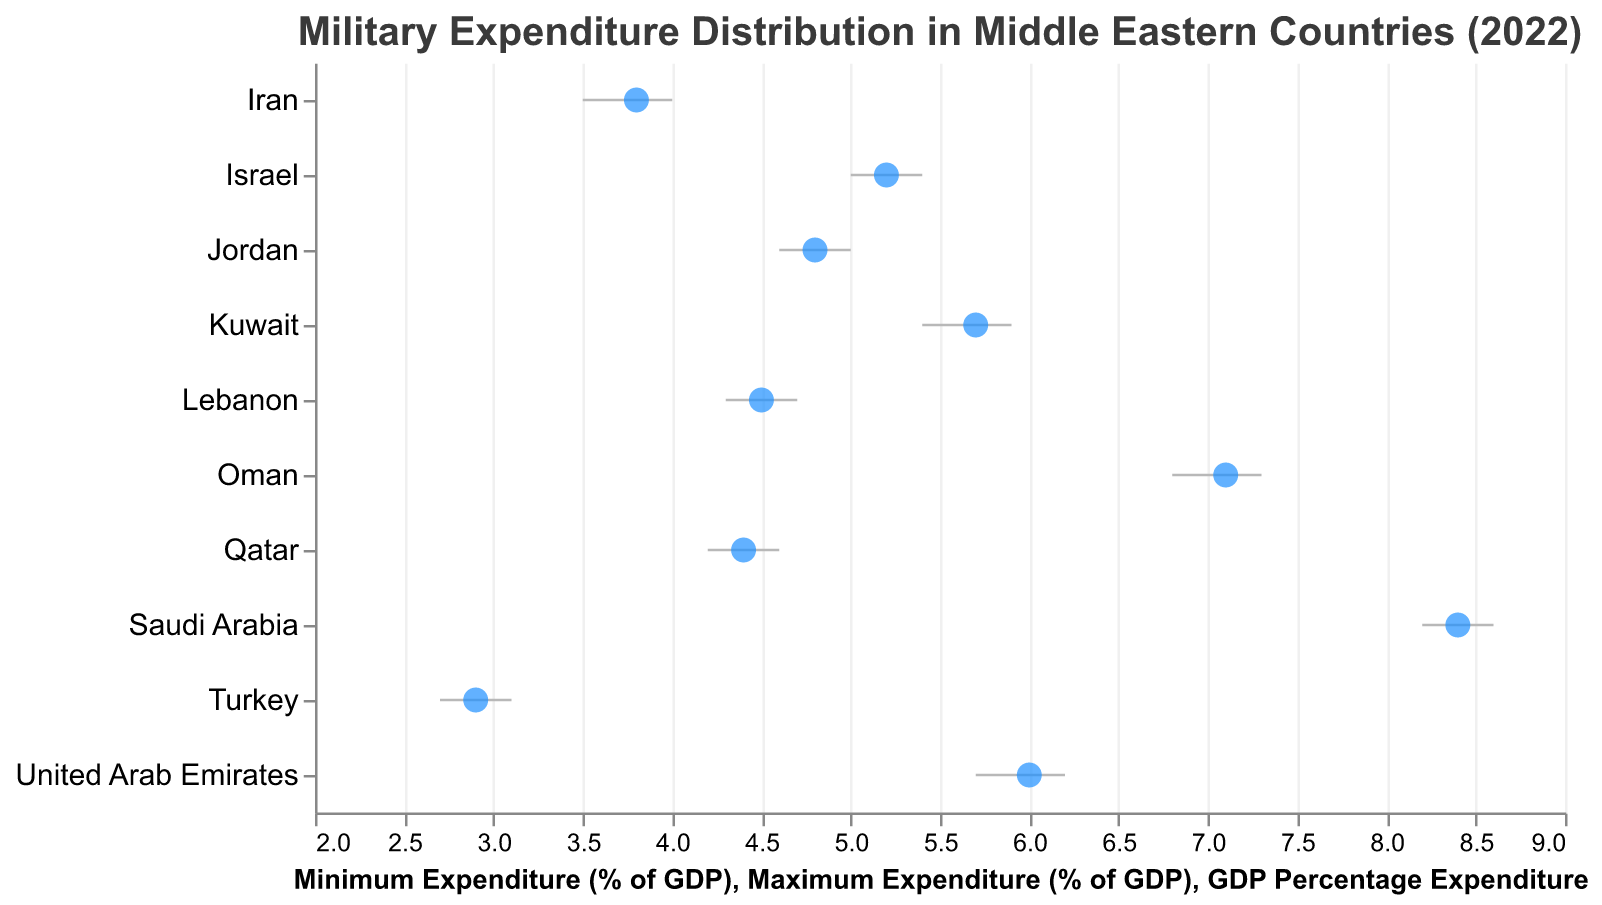Which country has the highest military expenditure as a percentage of GDP in 2022? According to the figure, Saudi Arabia has the highest military expenditure as a percentage of GDP with 8.4%.
Answer: Saudi Arabia What is the range of military expenditure for Israel in 2022? From the figure, the minimum expenditure for Israel is 5.0% and the maximum expenditure is 5.4%. Therefore, the range is calculated as 5.4 - 5.0.
Answer: 0.4% Which two countries have a military expenditure of approximately 4.4% of GDP in 2022? From the figure, both Lebanon and Qatar have a military expenditure close to 4.4% of GDP (Lebanon: 4.5%, Qatar: 4.4%).
Answer: Lebanon and Qatar Which country has the smallest range in military expenditure among all listed countries? The range can be found by subtracting the minimum expenditure from the maximum expenditure for each country. Israel has the smallest range of 0.4 (5.4 - 5.0).
Answer: Israel Compare the military expenditure between Oman and the United Arab Emirates. Which country spends more, and by how much? Oman has a military expenditure of 7.1% of GDP, while the United Arab Emirates has one of 6.0%. The difference is 7.1 - 6.0.
Answer: Oman by 1.1% What is the median military expenditure percentage among the countries listed in the figure? To find the median, first list the GDP percentages in ascending order: 2.9, 3.8, 4.4, 4.5, 4.8, 5.2, 5.7, 6.0, 7.1, 8.4. The median is the average of the middle two values: (4.8 + 5.2) / 2.
Answer: 5.0% Which country has a minimum military expenditure that is greater than or equal to Turkey's maximum military expenditure? Turkey's maximum military expenditure is 3.1%. From the figure, the countries with a minimum expenditure greater than or equal to 3.1% are Saudi Arabia (8.2%), Oman (6.8%), Israel (5.0%), Jordan (4.6%), Lebanon (4.3%), Iran (3.5%), Kuwait (5.4%), Qatar (4.2%), and UAE (5.7%).
Answer: Saudi Arabia, Oman, Israel, Jordan, Lebanon, Iran, Kuwait, Qatar, UAE Identify the country with the largest difference between minimum and maximum military expenditure percentages. Calculate the difference for each country: Saudi Arabia (0.4), Israel (0.4), Oman (0.5), Jordan (0.4), Lebanon (0.4), Turkey (0.4), Iran (0.5), Kuwait (0.5), Qatar (0.4), UAE (0.5). Several countries have the largest difference of 0.5%.
Answer: Oman, Iran, Kuwait, UAE Which country spends the least on military as a percentage of GDP? From the figure, Turkey has the lowest military expenditure percentage of 2.9% of GDP.
Answer: Turkey 